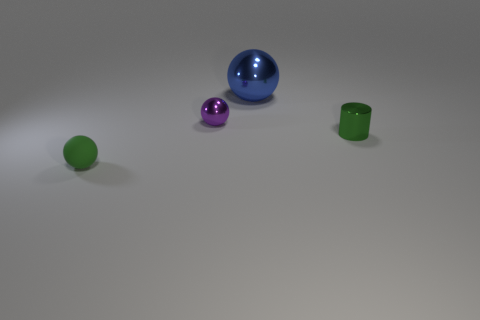There is a big thing; is it the same color as the tiny sphere to the right of the small green ball?
Ensure brevity in your answer.  No. What is the color of the shiny thing that is in front of the big blue shiny ball and to the right of the small purple thing?
Your response must be concise. Green. What number of other things are the same material as the large ball?
Your answer should be very brief. 2. Is the number of purple rubber spheres less than the number of blue shiny spheres?
Provide a succinct answer. Yes. Is the small cylinder made of the same material as the tiny sphere that is left of the purple metal ball?
Your answer should be very brief. No. What shape is the metal thing that is right of the big metal thing?
Your answer should be compact. Cylinder. Are there any other things of the same color as the tiny cylinder?
Give a very brief answer. Yes. Are there fewer large blue metallic balls in front of the large metallic ball than large blue rubber spheres?
Ensure brevity in your answer.  No. How many green metal objects are the same size as the blue ball?
Give a very brief answer. 0. What is the shape of the other tiny thing that is the same color as the rubber thing?
Your answer should be compact. Cylinder. 